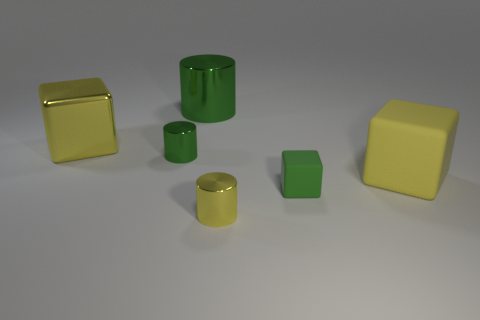Subtract all brown cylinders. How many yellow cubes are left? 2 Add 2 cyan shiny cylinders. How many objects exist? 8 Subtract all green cubes. How many cubes are left? 2 Subtract all big yellow cubes. Subtract all big yellow matte objects. How many objects are left? 3 Add 1 large yellow metallic blocks. How many large yellow metallic blocks are left? 2 Add 1 tiny green matte blocks. How many tiny green matte blocks exist? 2 Subtract 0 red cylinders. How many objects are left? 6 Subtract all brown blocks. Subtract all purple spheres. How many blocks are left? 3 